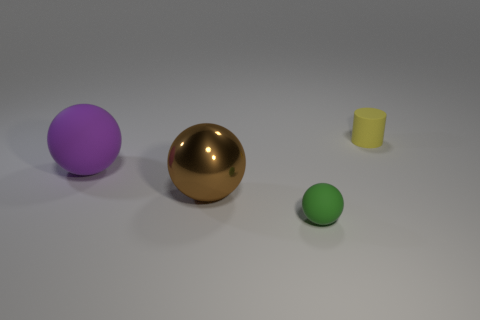What shape is the green thing that is the same material as the purple thing? The green object shares the spherical shape and appears to have a similar matte texture with the purple object, indicating that they are likely made of the same material. 